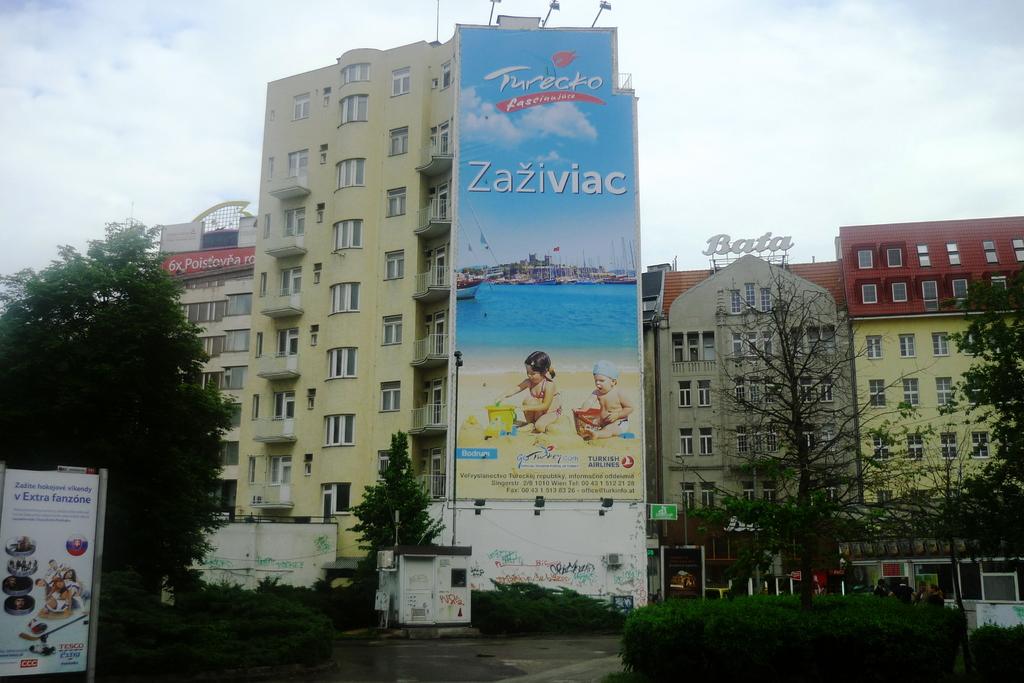What brand is seen on the billboard?
Offer a very short reply. Turecko. 